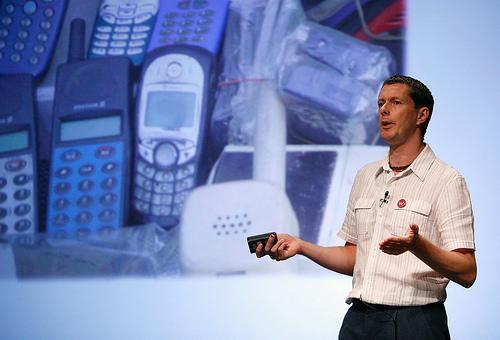How many things is he holding?
Give a very brief answer. 1. 